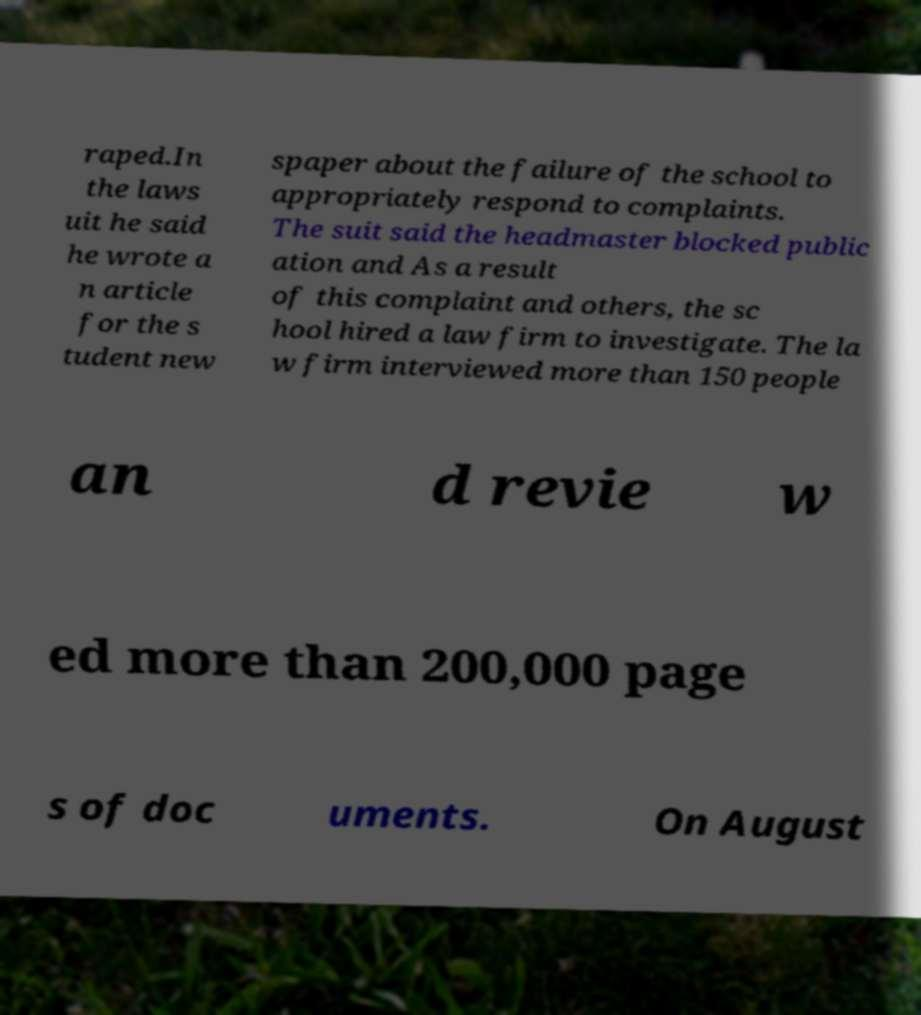Please identify and transcribe the text found in this image. raped.In the laws uit he said he wrote a n article for the s tudent new spaper about the failure of the school to appropriately respond to complaints. The suit said the headmaster blocked public ation and As a result of this complaint and others, the sc hool hired a law firm to investigate. The la w firm interviewed more than 150 people an d revie w ed more than 200,000 page s of doc uments. On August 